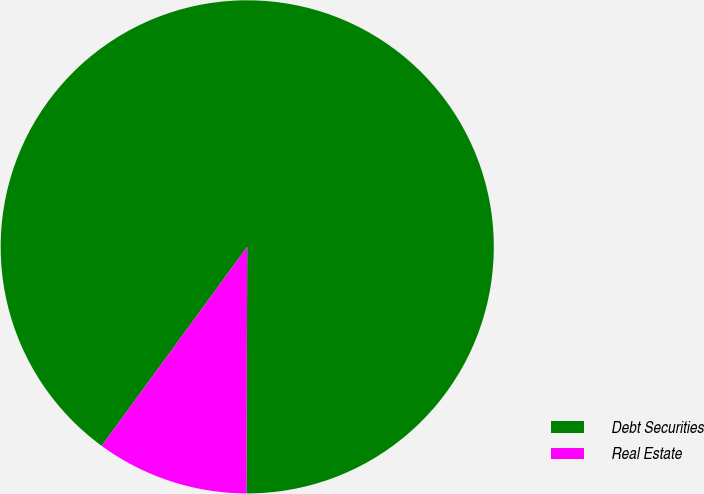Convert chart to OTSL. <chart><loc_0><loc_0><loc_500><loc_500><pie_chart><fcel>Debt Securities<fcel>Real Estate<nl><fcel>90.0%<fcel>10.0%<nl></chart> 